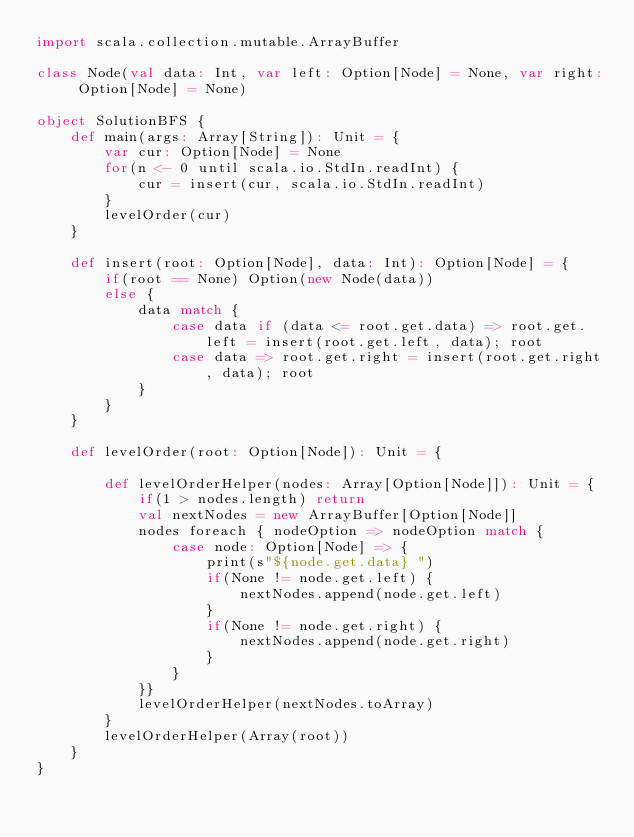Convert code to text. <code><loc_0><loc_0><loc_500><loc_500><_Scala_>import scala.collection.mutable.ArrayBuffer

class Node(val data: Int, var left: Option[Node] = None, var right: Option[Node] = None)

object SolutionBFS {
    def main(args: Array[String]): Unit = {
        var cur: Option[Node] = None
        for(n <- 0 until scala.io.StdIn.readInt) {
            cur = insert(cur, scala.io.StdIn.readInt)
        }
        levelOrder(cur)
    }

    def insert(root: Option[Node], data: Int): Option[Node] = {
        if(root == None) Option(new Node(data))
        else {
            data match {
                case data if (data <= root.get.data) => root.get.left = insert(root.get.left, data); root
                case data => root.get.right = insert(root.get.right, data); root
            }
        }
    }

    def levelOrder(root: Option[Node]): Unit = {

        def levelOrderHelper(nodes: Array[Option[Node]]): Unit = {
            if(1 > nodes.length) return
            val nextNodes = new ArrayBuffer[Option[Node]]
            nodes foreach { nodeOption => nodeOption match {
                case node: Option[Node] => {
                    print(s"${node.get.data} ")
                    if(None != node.get.left) {
                        nextNodes.append(node.get.left)
                    }
                    if(None != node.get.right) {
                        nextNodes.append(node.get.right)
                    }
                }
            }}
            levelOrderHelper(nextNodes.toArray)
        }
        levelOrderHelper(Array(root))
    }
}
</code> 